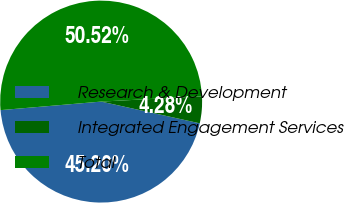Convert chart. <chart><loc_0><loc_0><loc_500><loc_500><pie_chart><fcel>Research & Development<fcel>Integrated Engagement Services<fcel>Total<nl><fcel>45.2%<fcel>4.28%<fcel>50.52%<nl></chart> 